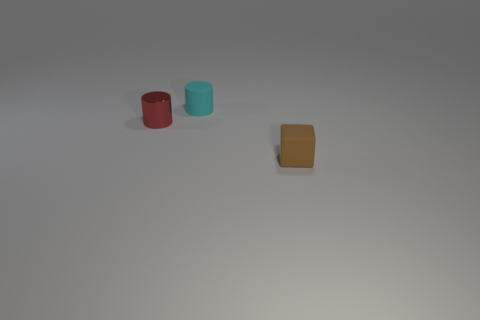Add 2 tiny matte things. How many objects exist? 5 Subtract all cubes. How many objects are left? 2 Add 1 tiny metallic objects. How many tiny metallic objects exist? 2 Subtract 0 gray cylinders. How many objects are left? 3 Subtract all brown matte blocks. Subtract all small cyan rubber cylinders. How many objects are left? 1 Add 2 red cylinders. How many red cylinders are left? 3 